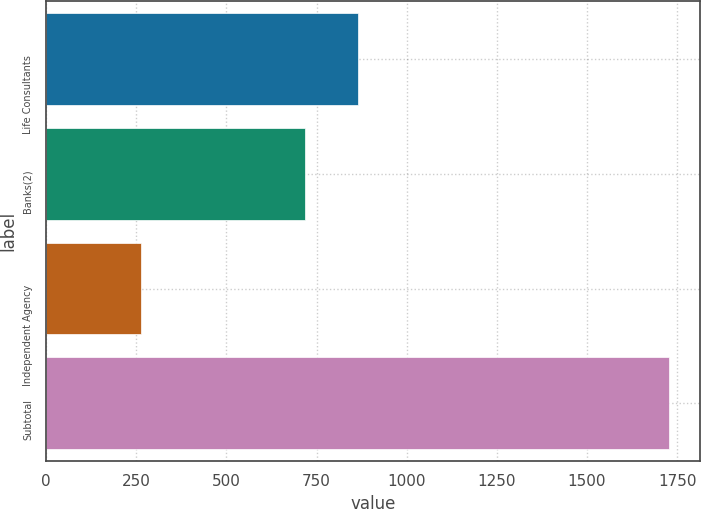Convert chart. <chart><loc_0><loc_0><loc_500><loc_500><bar_chart><fcel>Life Consultants<fcel>Banks(2)<fcel>Independent Agency<fcel>Subtotal<nl><fcel>865.6<fcel>719<fcel>262<fcel>1728<nl></chart> 